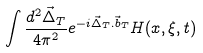Convert formula to latex. <formula><loc_0><loc_0><loc_500><loc_500>\int \frac { d ^ { 2 } \vec { \Delta } _ { T } } { 4 \pi ^ { 2 } } e ^ { - i \vec { \Delta } _ { T } . \vec { b } _ { T } } H ( x , \xi , t ) \,</formula> 